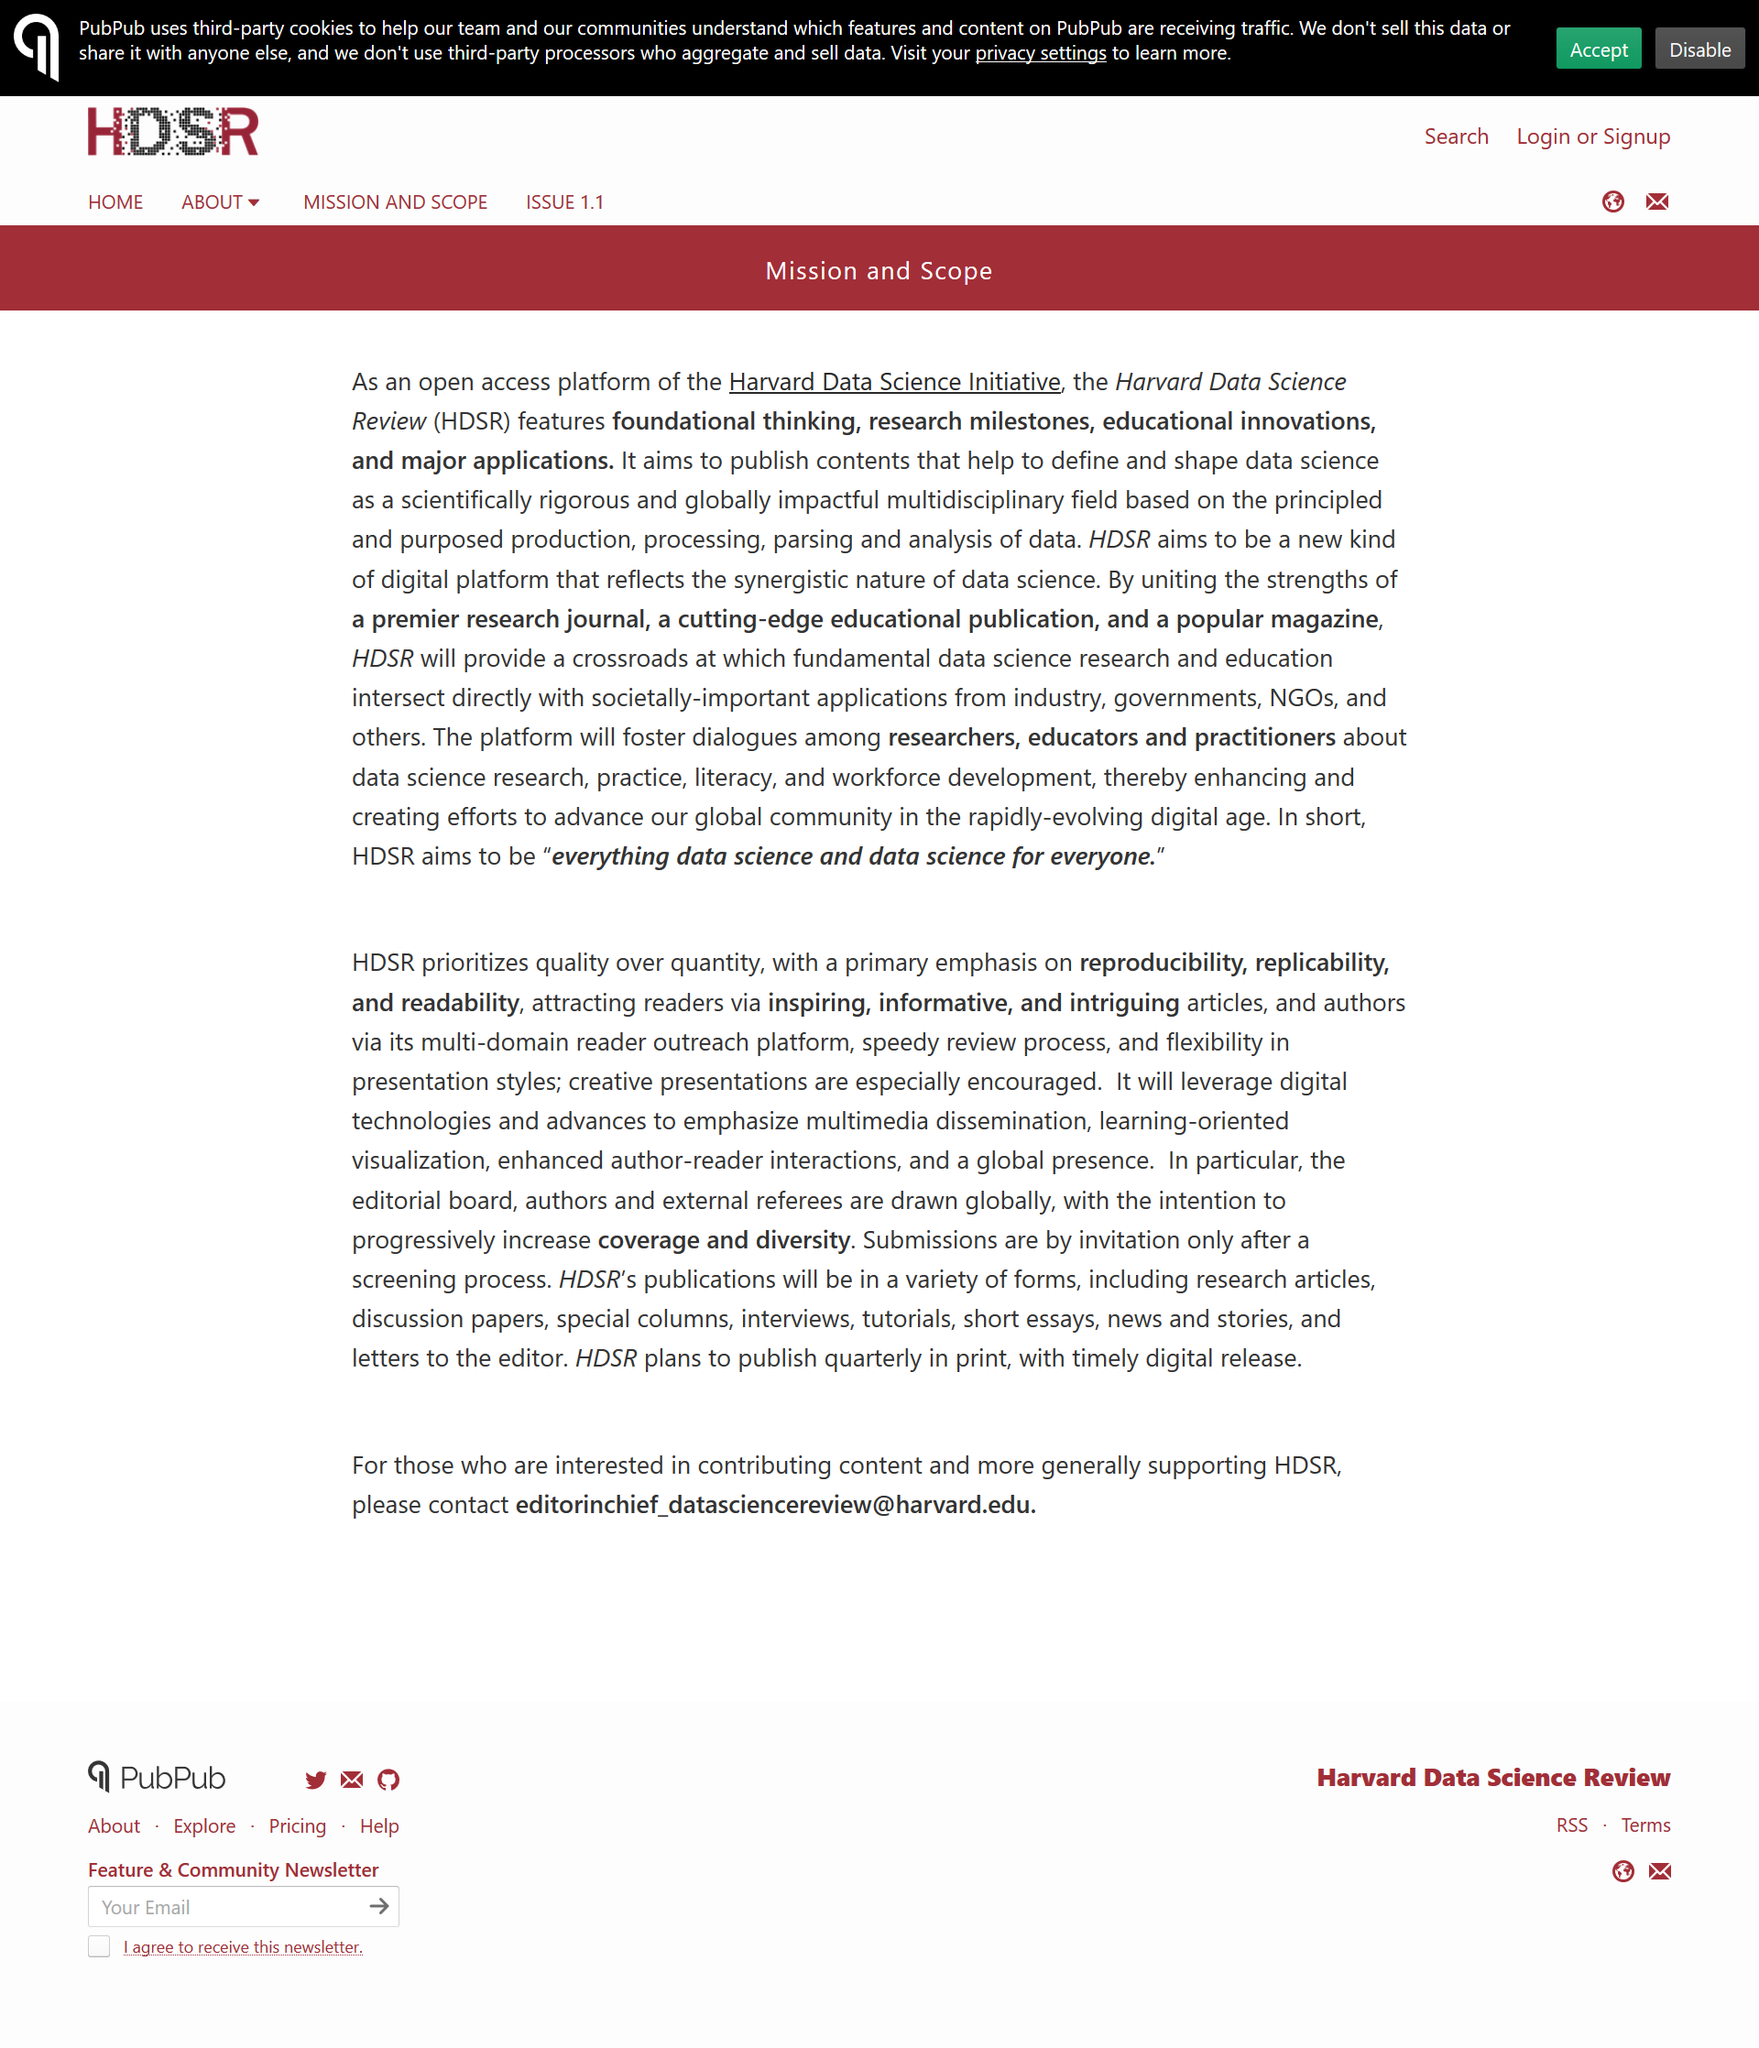Highlight a few significant elements in this photo. The acronym "HDSR" stands for "Harvard Data Science Review. The primary emphases of the Harvard Data Science Review are reproducibility, replicability, and readability. Yes, there is contact information available for the HDSR. 